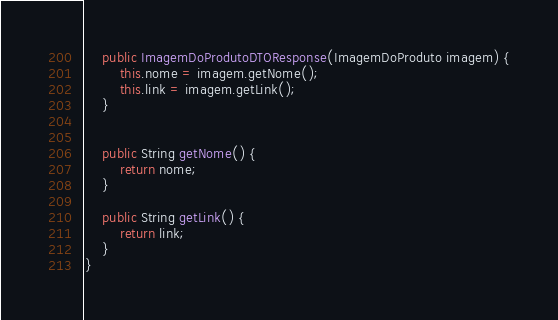<code> <loc_0><loc_0><loc_500><loc_500><_Java_>
    public ImagemDoProdutoDTOResponse(ImagemDoProduto imagem) {
        this.nome = imagem.getNome();
        this.link = imagem.getLink();
    }


    public String getNome() {
        return nome;
    }

    public String getLink() {
        return link;
    }
}</code> 